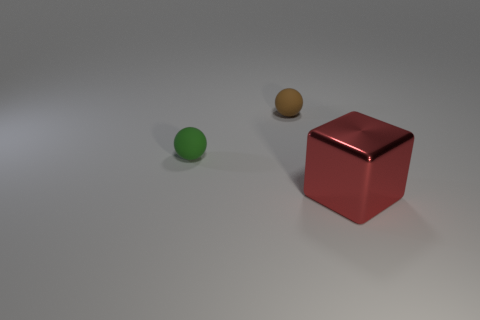Add 2 brown rubber balls. How many objects exist? 5 Subtract all brown balls. How many balls are left? 1 Subtract all big red metal blocks. Subtract all matte things. How many objects are left? 0 Add 1 metallic blocks. How many metallic blocks are left? 2 Add 3 small brown matte objects. How many small brown matte objects exist? 4 Subtract 1 red blocks. How many objects are left? 2 Subtract all spheres. How many objects are left? 1 Subtract 1 cubes. How many cubes are left? 0 Subtract all brown balls. Subtract all purple cylinders. How many balls are left? 1 